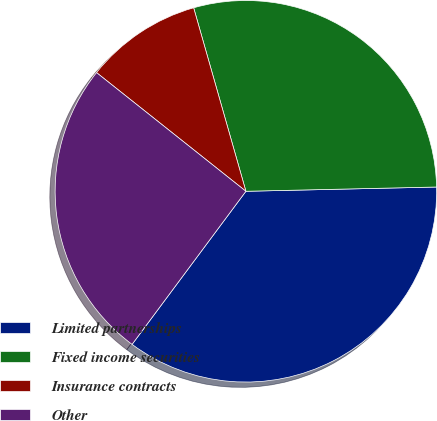Convert chart to OTSL. <chart><loc_0><loc_0><loc_500><loc_500><pie_chart><fcel>Limited partnerships<fcel>Fixed income securities<fcel>Insurance contracts<fcel>Other<nl><fcel>35.53%<fcel>29.06%<fcel>9.9%<fcel>25.51%<nl></chart> 